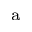<formula> <loc_0><loc_0><loc_500><loc_500>^ { a }</formula> 